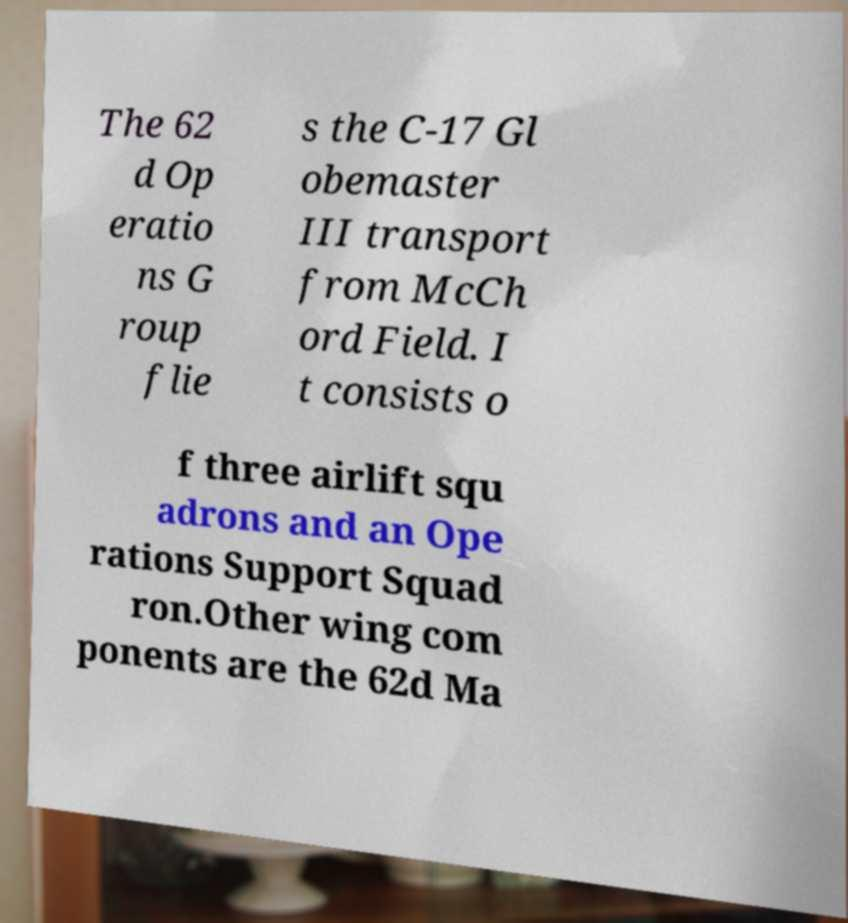Can you accurately transcribe the text from the provided image for me? The 62 d Op eratio ns G roup flie s the C-17 Gl obemaster III transport from McCh ord Field. I t consists o f three airlift squ adrons and an Ope rations Support Squad ron.Other wing com ponents are the 62d Ma 